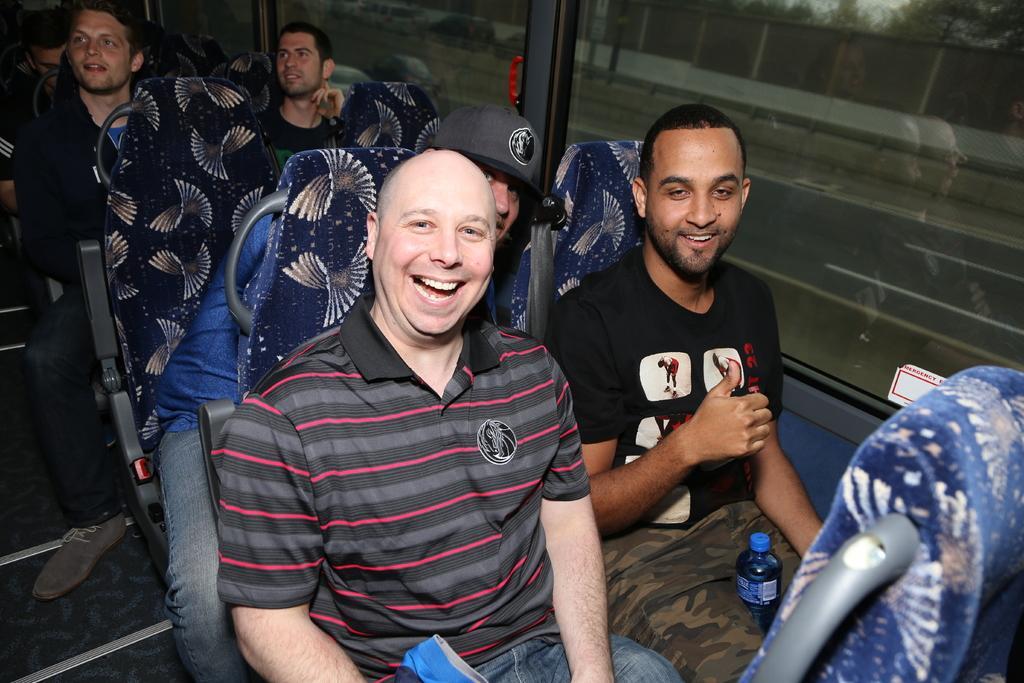Please provide a concise description of this image. In this picture there are group of people, it seems to be they are sitting in a bus, the person who is center of the image is laughing. 